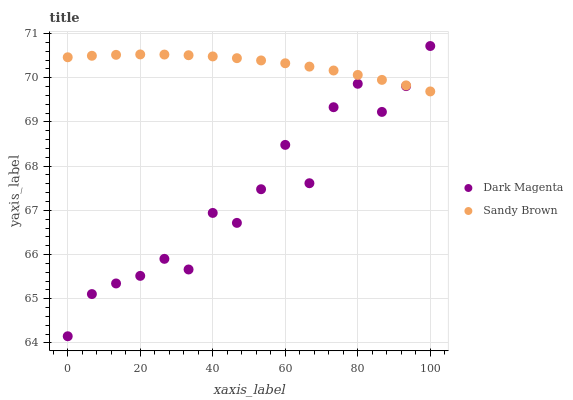Does Dark Magenta have the minimum area under the curve?
Answer yes or no. Yes. Does Sandy Brown have the maximum area under the curve?
Answer yes or no. Yes. Does Dark Magenta have the maximum area under the curve?
Answer yes or no. No. Is Sandy Brown the smoothest?
Answer yes or no. Yes. Is Dark Magenta the roughest?
Answer yes or no. Yes. Is Dark Magenta the smoothest?
Answer yes or no. No. Does Dark Magenta have the lowest value?
Answer yes or no. Yes. Does Dark Magenta have the highest value?
Answer yes or no. Yes. Does Dark Magenta intersect Sandy Brown?
Answer yes or no. Yes. Is Dark Magenta less than Sandy Brown?
Answer yes or no. No. Is Dark Magenta greater than Sandy Brown?
Answer yes or no. No. 